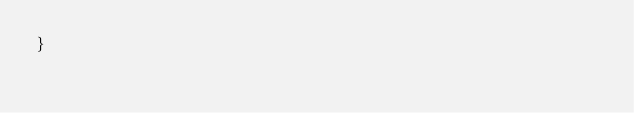Convert code to text. <code><loc_0><loc_0><loc_500><loc_500><_Java_>}
</code> 